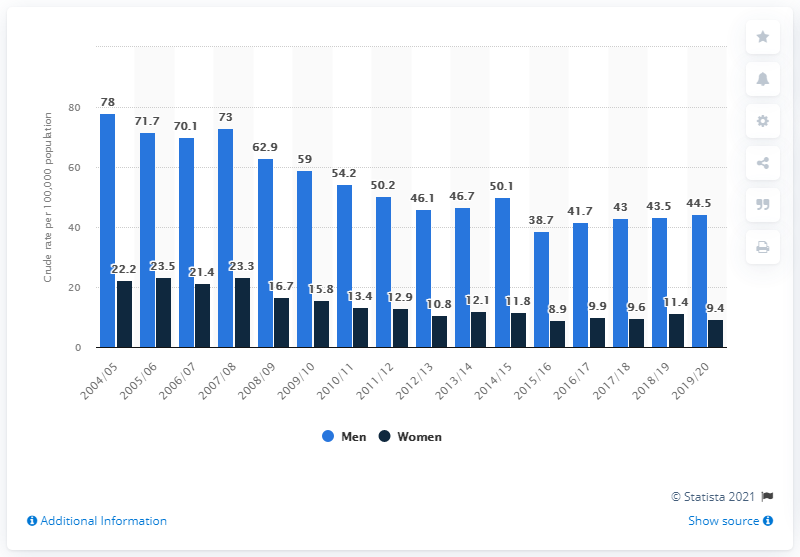Indicate a few pertinent items in this graphic. In the 2019/2020 fiscal year, the rate of coronary artery bypass graft for women in Scotland was 9.4%. According to data from Scotland in the 2019/2020 fiscal year, the rate of coronary artery bypass graft procedures performed on men was 44.5%. 